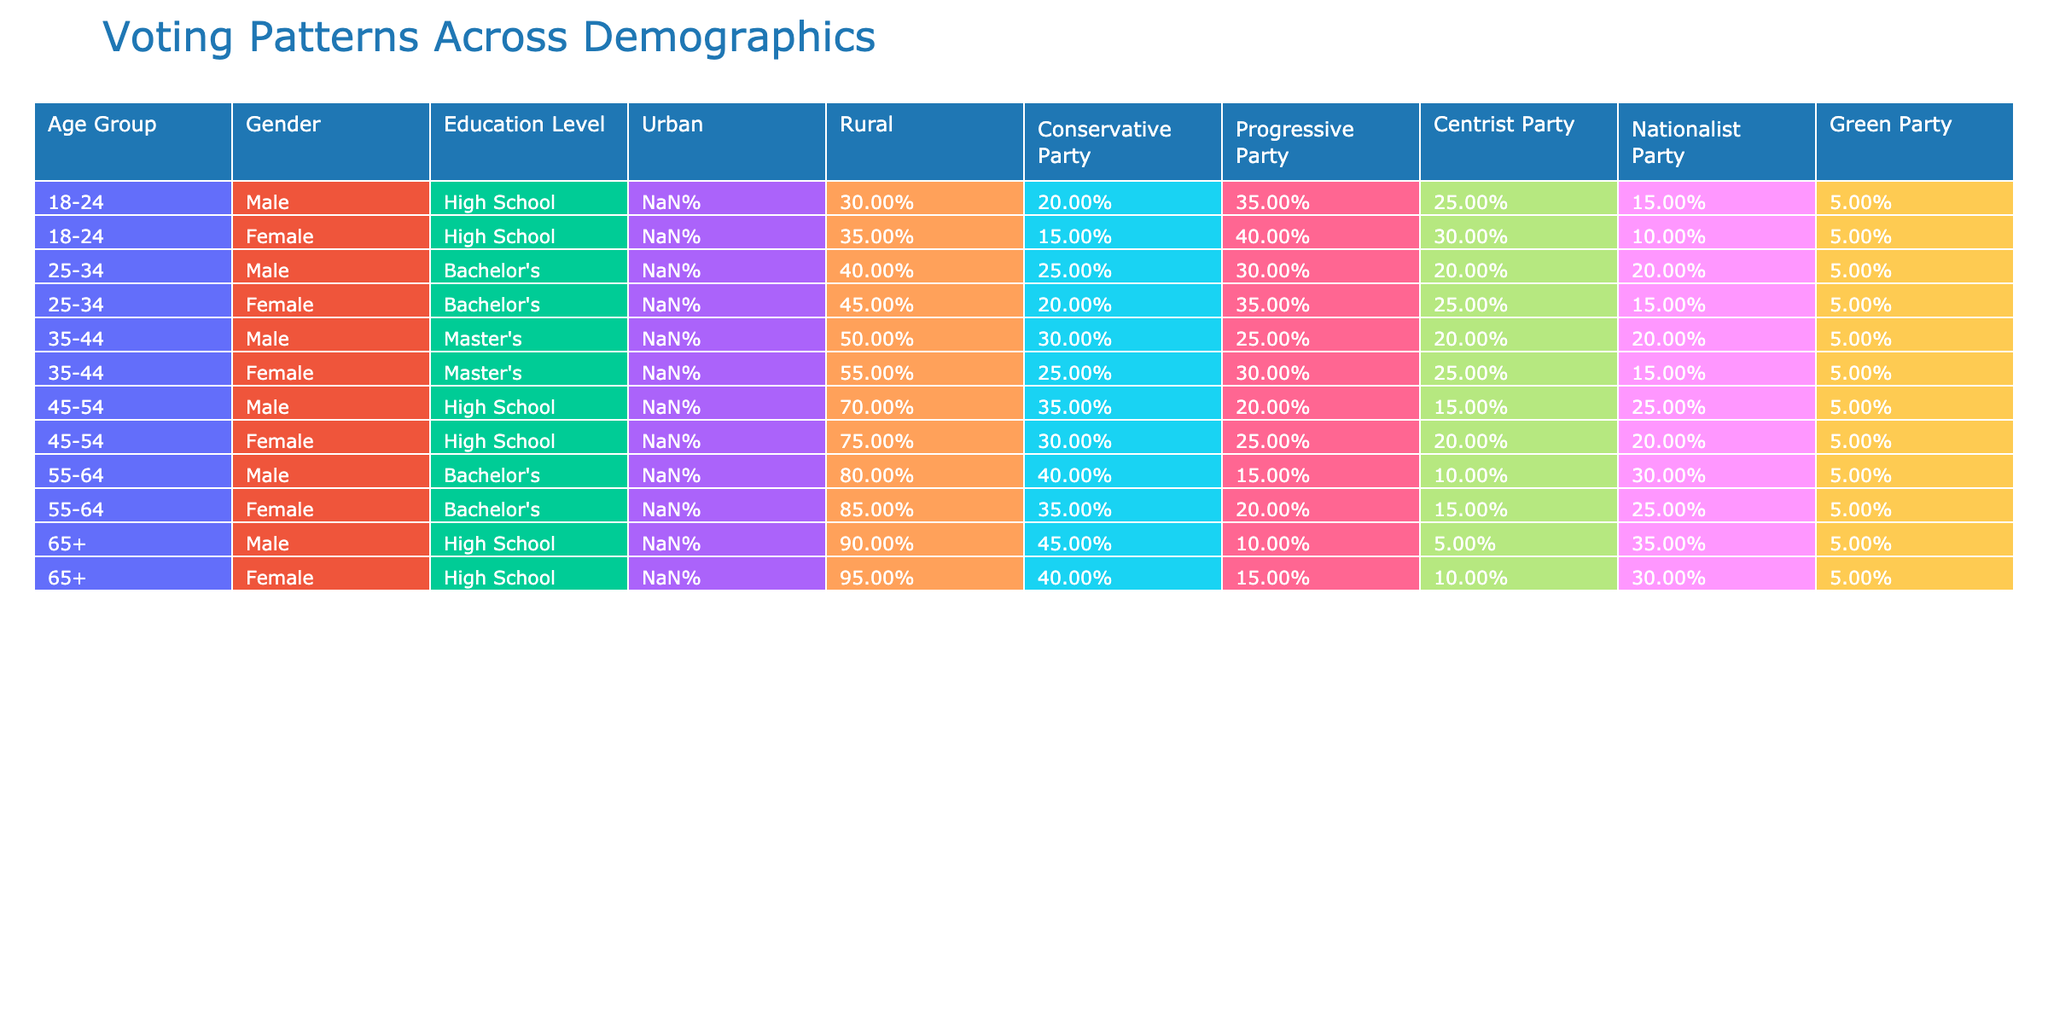What percentage of 18-24-year-old males voted for the Conservative Party? The table indicates that 20% of 18-24-year-old males voted for the Conservative Party.
Answer: 20% Which age group has the highest percentage of urban voters? The 65+ age group has the highest percentage of urban voters at 85%.
Answer: 85% What is the difference in the percentage of votes for the Green Party between 25-34-year-old males and females? Males aged 25-34 voted 5% for the Green Party, while females voted 5%. The difference is 5% - 5% = 0%.
Answer: 0% Did more females in the 35-44 age group vote for the Progressive Party than males? Yes, 30% of 35-44-year-old females voted for the Progressive Party compared to 25% of males.
Answer: Yes What is the average percentage of votes for the Centrist Party across all age groups for females? Summing the percentages for females (15% + 30% + 20% + 25%) gives 90%. There are 4 data points, so the average is 90% / 4 = 22.5%.
Answer: 22.5% Which gender has a higher percentage of support for the Nationalist Party in the 45-54 age group? Males received 25% and females received 20% for the Nationalist Party in this age group. Males have a higher percentage.
Answer: Males What is the total percentage of votes for all parties combined for 55-64 year-old females? Adding the percentages of all parties for 55-64 females gives 5% + 15% + 20% + 25% + 10% + 35% + 5% = 100%.
Answer: 100% Which demographic group showed the least support for the Conservative Party? The females in the 18-24 age group showed the least support with 15%.
Answer: 15% What percentage of urban voters aged 45-54 voted for the Progressive Party? 25% of urban voters aged 45-54 voted for the Progressive Party according to the table.
Answer: 25% Did the voting patterns indicate that voters with a Master's degree are more supportive of the Progressive Party than the Nationalist Party? Yes, for both males and females with a Master's degree, the support for the Progressive Party (30% female, 25% male) is higher than for the Nationalist Party (20% both genders).
Answer: Yes What is the median percentage of Green Party votes across all age groups and genders? The percentages for the Green Party are 5%, 5%, 5%, 5%, 5%, 5%, 10%, 5%. Ordering these values, the median (the middle value) is 5%.
Answer: 5% 